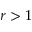<formula> <loc_0><loc_0><loc_500><loc_500>r > 1</formula> 